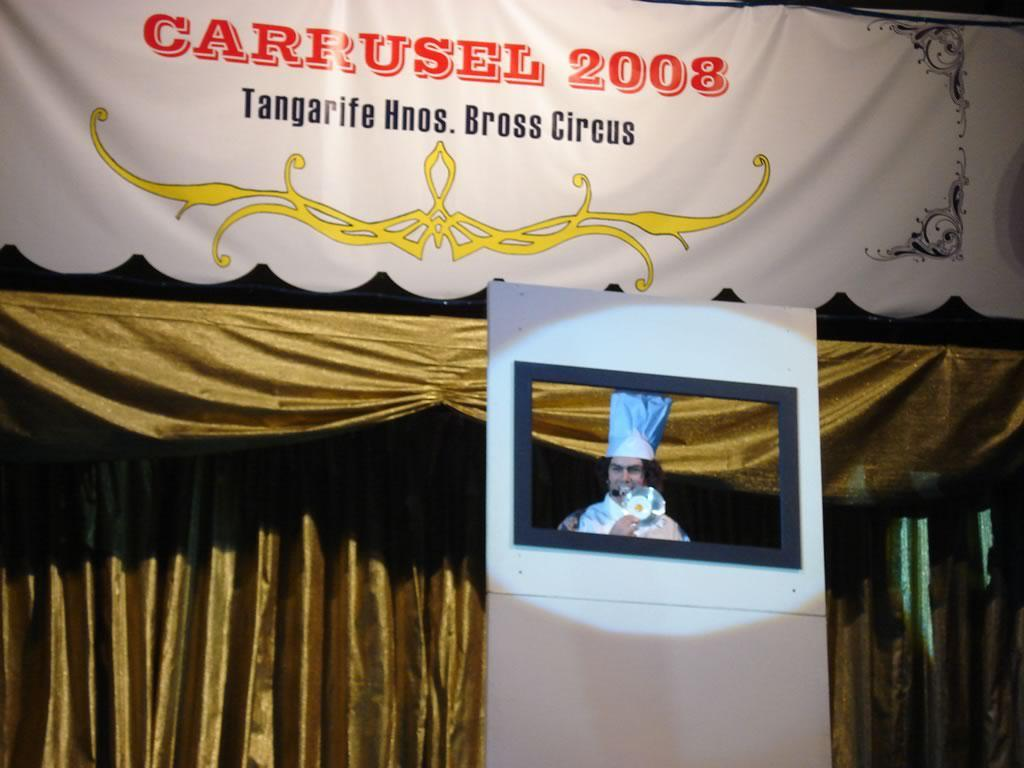What object in the image contains a person? The photo frame in the image contains a person. What is the purpose of the photo frame? The photo frame is used to display a photo of a person. What else can be seen in the image besides the photo frame? There is a curtain with text in the image. What type of plastic material is used to make the leaf in the image? There is no leaf present in the image, so it is not possible to determine the type of plastic material used. 